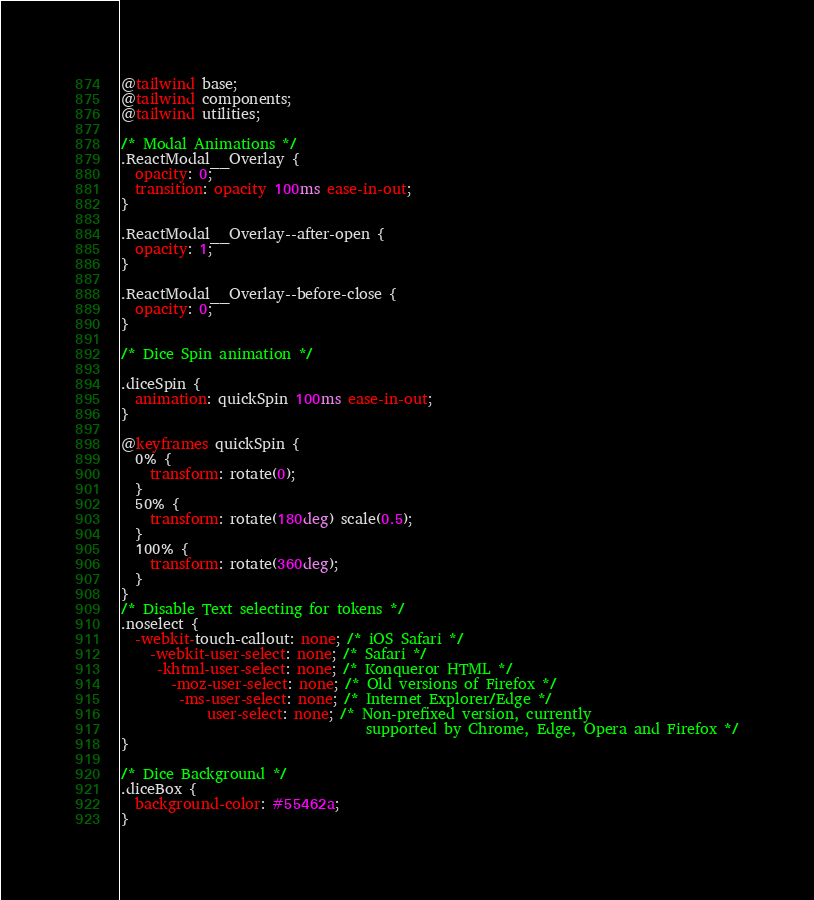<code> <loc_0><loc_0><loc_500><loc_500><_CSS_>@tailwind base;
@tailwind components;
@tailwind utilities;

/* Modal Animations */
.ReactModal__Overlay {
  opacity: 0;
  transition: opacity 100ms ease-in-out;
}

.ReactModal__Overlay--after-open {
  opacity: 1;
}

.ReactModal__Overlay--before-close {
  opacity: 0;
}

/* Dice Spin animation */

.diceSpin {
  animation: quickSpin 100ms ease-in-out;
}

@keyframes quickSpin {
  0% {
    transform: rotate(0);
  }
  50% {
    transform: rotate(180deg) scale(0.5);
  }
  100% {
    transform: rotate(360deg);
  }
}
/* Disable Text selecting for tokens */
.noselect {
  -webkit-touch-callout: none; /* iOS Safari */
    -webkit-user-select: none; /* Safari */
     -khtml-user-select: none; /* Konqueror HTML */
       -moz-user-select: none; /* Old versions of Firefox */
        -ms-user-select: none; /* Internet Explorer/Edge */
            user-select: none; /* Non-prefixed version, currently
                                  supported by Chrome, Edge, Opera and Firefox */
}

/* Dice Background */
.diceBox {
  background-color: #55462a;
}
</code> 